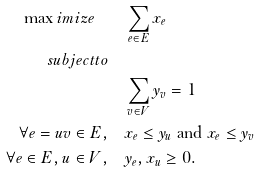Convert formula to latex. <formula><loc_0><loc_0><loc_500><loc_500>\max i m i z e \quad & \sum _ { e \in E } x _ { e } \\ s u b j e c t t o \quad & \\ & \sum _ { v \in V } y _ { v } = 1 \\ \forall e = u v \in E , \quad & x _ { e } \leq y _ { u } \text { and } x _ { e } \leq y _ { v } \\ \forall e \in E , u \in V , \quad & y _ { e } , x _ { u } \geq 0 .</formula> 